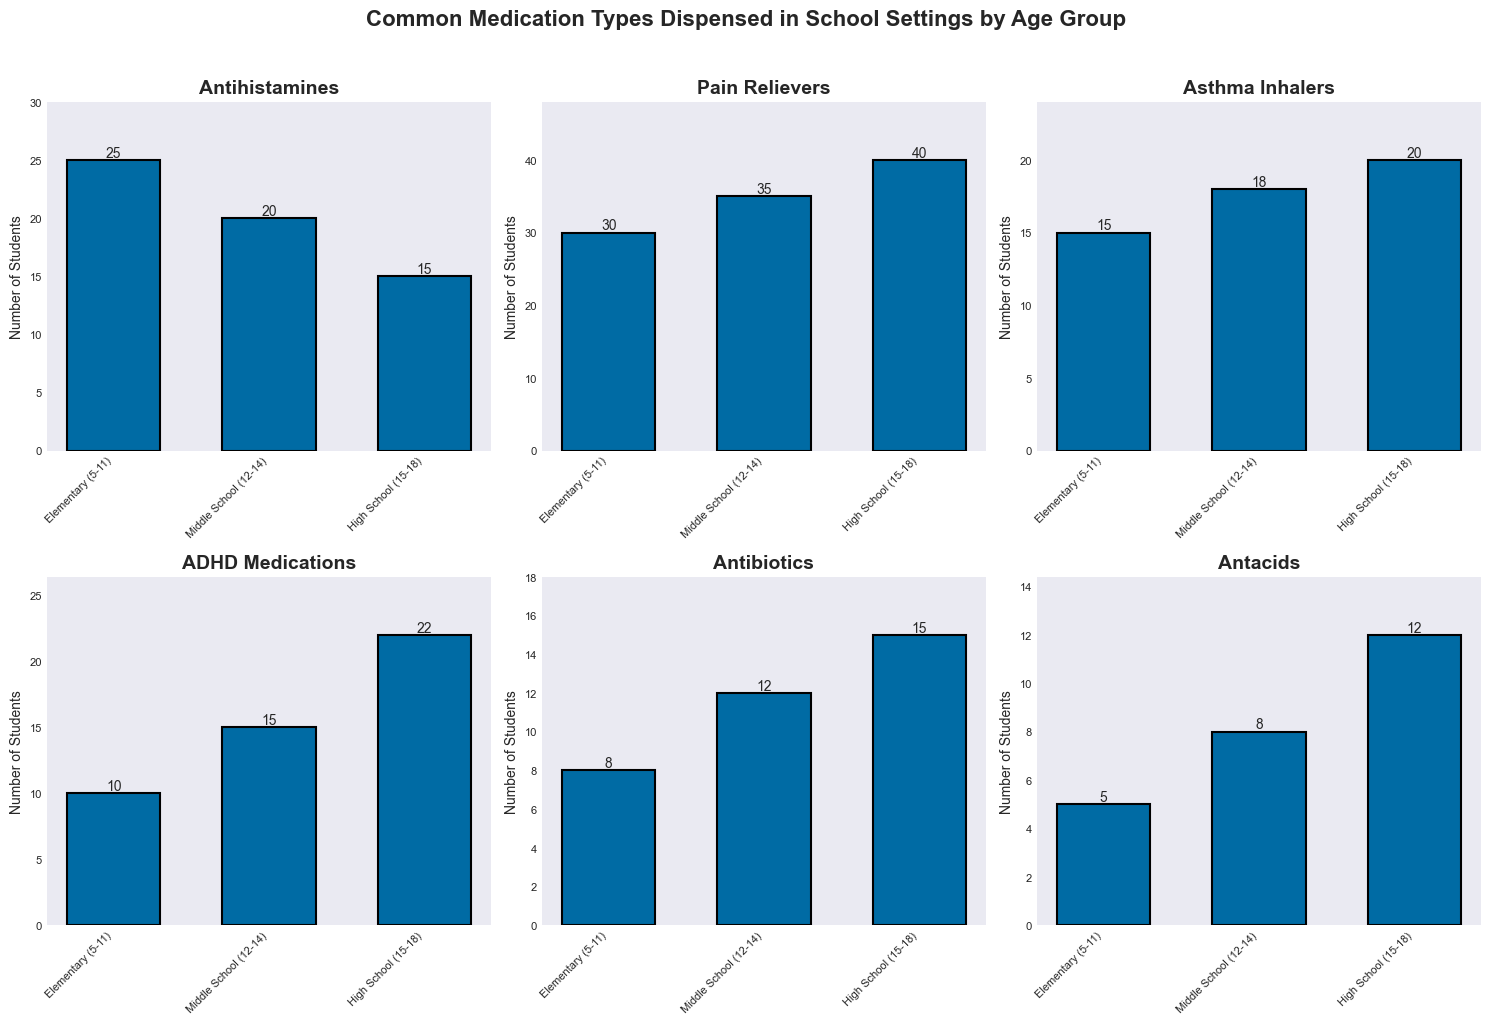Which age group is given the most pain relievers? By looking at the Pain Relievers subplot, the bar for High School (15-18) students is the tallest.
Answer: High School (15-18) How many antihistamines are dispensed to elementary students? In the Antihistamines subplot, the bar for Elementary (5-11) students reaches up to 25.
Answer: 25 What is the total number of students who use asthma inhalers across all age groups? Sum the values from the Asthma Inhalers subplot: 15 (Elementary) + 18 (Middle School) + 20 (High School).
Answer: 53 Which medication type has the highest average number of students using it across all age groups? Calculate the average for each medication type and compare. For example, the Pain Relievers subplot categories show total counts of 30, 35, and 40, so the average is (30+35+40)/3 = 35. After calculating for all, we compare averages.
Answer: Pain Relievers Is the number of antibiotics dispensed to high school students greater than double the number dispensed to elementary students? Check the Antibiotics subplot: High School students have 15, Elementary students have 8. Compute 2 x 8 = 16 and compare. 15 is less than 16.
Answer: No Which age group uses the fewest ADHD medications? By reviewing the ADHD Medications subplot, the bar for Elementary (5-11) is the shortest.
Answer: Elementary (5-11) What’s the difference in the number of antacids dispensed between middle school and high school students? In the Antacids subplot, Middle School students are at 8 and High School students are at 12. Compute the difference: 12 - 8.
Answer: 4 How do the average numbers of students taking asthma inhalers and antibiotics compare? Calculate averages: Asthma Inhalers: (15+18+20)/3 = 17.67, Antibiotics: (8+12+15)/3 = 11.67. Compare the averages.
Answer: Asthma Inhalers > Antibiotics Which medication type dispensed to middle school students is the least common? Middle School subplot: Antacids at 8 is the smallest value.
Answer: Antacids Do elementary school students receive more antihistamines or asthma inhalers? Check Elementary subplot for both medications: Antihistamines show 25, Asthma Inhalers show 15. Compare values.
Answer: Antihistamines 